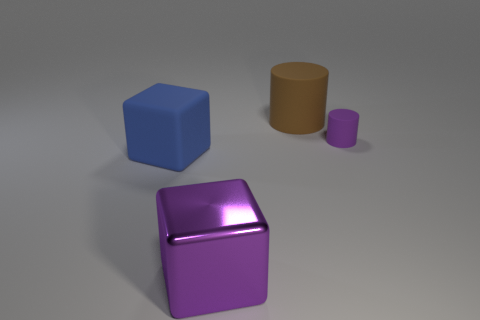Add 2 big metal things. How many objects exist? 6 Subtract 0 green cubes. How many objects are left? 4 Subtract 1 blocks. How many blocks are left? 1 Subtract all blue blocks. Subtract all green spheres. How many blocks are left? 1 Subtract all red blocks. How many brown cylinders are left? 1 Subtract all big blocks. Subtract all big purple objects. How many objects are left? 1 Add 2 purple objects. How many purple objects are left? 4 Add 4 big blue matte objects. How many big blue matte objects exist? 5 Subtract all purple cylinders. How many cylinders are left? 1 